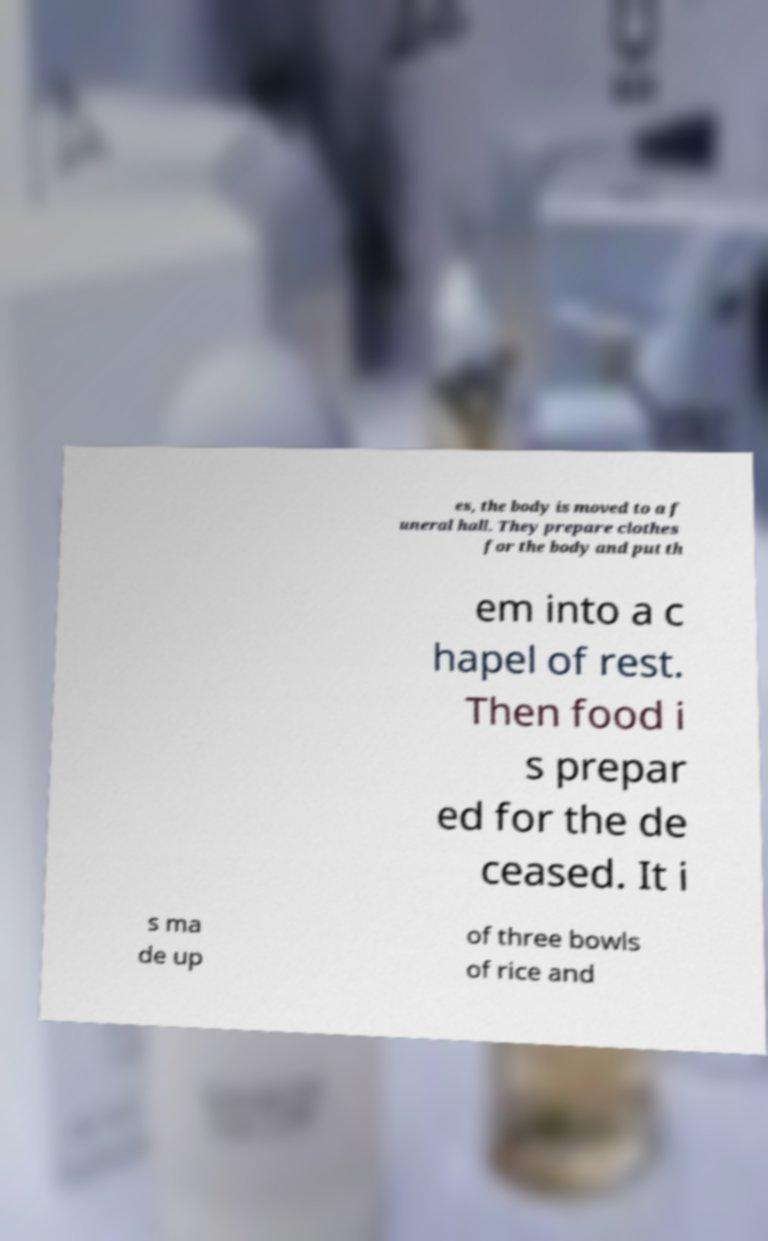I need the written content from this picture converted into text. Can you do that? es, the body is moved to a f uneral hall. They prepare clothes for the body and put th em into a c hapel of rest. Then food i s prepar ed for the de ceased. It i s ma de up of three bowls of rice and 